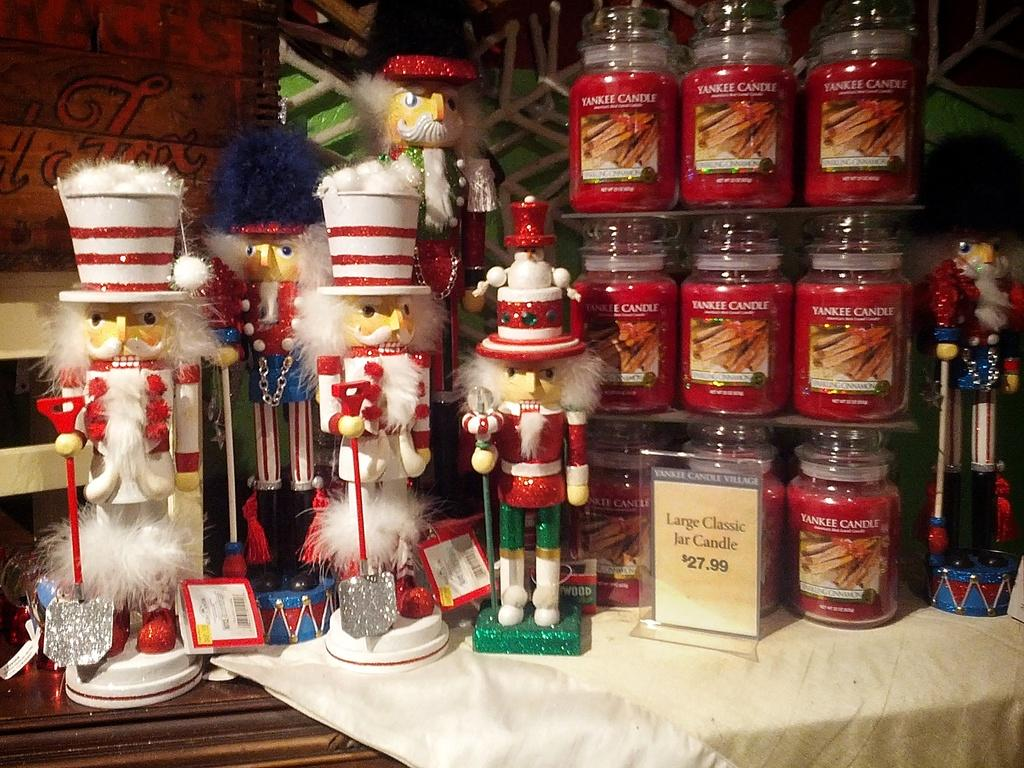<image>
Relay a brief, clear account of the picture shown. A Christmas display with large classic jar candles on sale. 